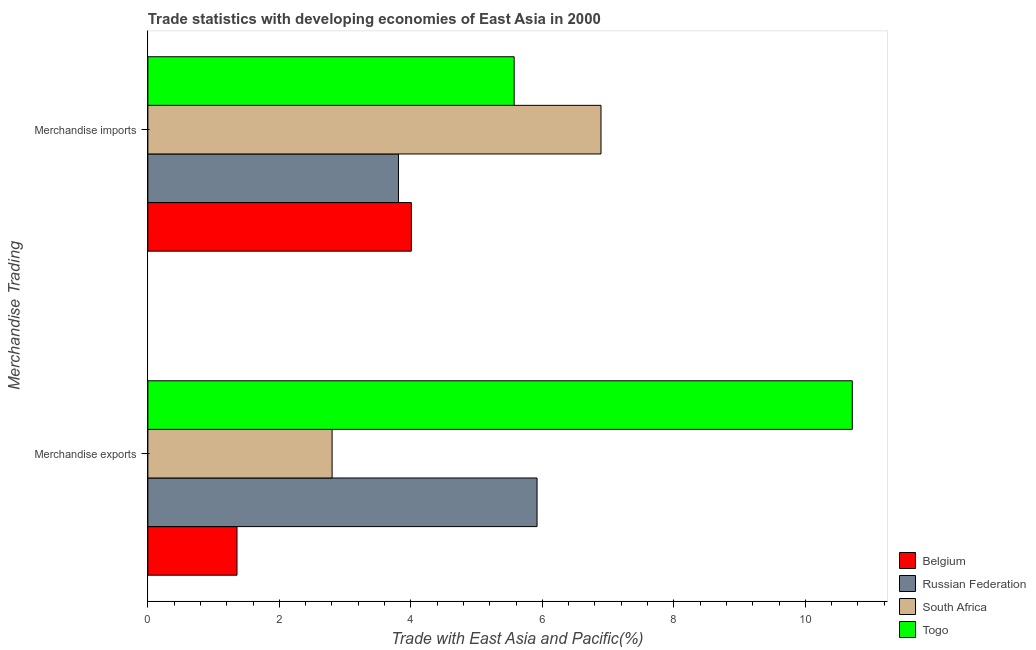Are the number of bars per tick equal to the number of legend labels?
Provide a short and direct response. Yes. Are the number of bars on each tick of the Y-axis equal?
Make the answer very short. Yes. How many bars are there on the 2nd tick from the top?
Provide a short and direct response. 4. How many bars are there on the 1st tick from the bottom?
Give a very brief answer. 4. What is the label of the 2nd group of bars from the top?
Provide a short and direct response. Merchandise exports. What is the merchandise imports in Belgium?
Provide a short and direct response. 4.01. Across all countries, what is the maximum merchandise exports?
Offer a very short reply. 10.71. Across all countries, what is the minimum merchandise exports?
Offer a very short reply. 1.36. In which country was the merchandise imports maximum?
Provide a short and direct response. South Africa. In which country was the merchandise imports minimum?
Ensure brevity in your answer.  Russian Federation. What is the total merchandise exports in the graph?
Your answer should be very brief. 20.79. What is the difference between the merchandise exports in Togo and that in Belgium?
Give a very brief answer. 9.36. What is the difference between the merchandise imports in Togo and the merchandise exports in Belgium?
Provide a short and direct response. 4.22. What is the average merchandise exports per country?
Your answer should be very brief. 5.2. What is the difference between the merchandise imports and merchandise exports in Belgium?
Offer a terse response. 2.65. In how many countries, is the merchandise exports greater than 9.6 %?
Offer a very short reply. 1. What is the ratio of the merchandise imports in Belgium to that in South Africa?
Your answer should be very brief. 0.58. Is the merchandise imports in Togo less than that in South Africa?
Provide a succinct answer. Yes. What does the 2nd bar from the top in Merchandise imports represents?
Your answer should be very brief. South Africa. Are all the bars in the graph horizontal?
Make the answer very short. Yes. How many countries are there in the graph?
Your answer should be compact. 4. Are the values on the major ticks of X-axis written in scientific E-notation?
Make the answer very short. No. Where does the legend appear in the graph?
Your response must be concise. Bottom right. What is the title of the graph?
Make the answer very short. Trade statistics with developing economies of East Asia in 2000. What is the label or title of the X-axis?
Offer a very short reply. Trade with East Asia and Pacific(%). What is the label or title of the Y-axis?
Offer a very short reply. Merchandise Trading. What is the Trade with East Asia and Pacific(%) in Belgium in Merchandise exports?
Ensure brevity in your answer.  1.36. What is the Trade with East Asia and Pacific(%) of Russian Federation in Merchandise exports?
Give a very brief answer. 5.92. What is the Trade with East Asia and Pacific(%) in South Africa in Merchandise exports?
Give a very brief answer. 2.8. What is the Trade with East Asia and Pacific(%) in Togo in Merchandise exports?
Make the answer very short. 10.71. What is the Trade with East Asia and Pacific(%) of Belgium in Merchandise imports?
Your answer should be very brief. 4.01. What is the Trade with East Asia and Pacific(%) in Russian Federation in Merchandise imports?
Make the answer very short. 3.81. What is the Trade with East Asia and Pacific(%) in South Africa in Merchandise imports?
Ensure brevity in your answer.  6.89. What is the Trade with East Asia and Pacific(%) of Togo in Merchandise imports?
Give a very brief answer. 5.57. Across all Merchandise Trading, what is the maximum Trade with East Asia and Pacific(%) in Belgium?
Give a very brief answer. 4.01. Across all Merchandise Trading, what is the maximum Trade with East Asia and Pacific(%) of Russian Federation?
Make the answer very short. 5.92. Across all Merchandise Trading, what is the maximum Trade with East Asia and Pacific(%) of South Africa?
Keep it short and to the point. 6.89. Across all Merchandise Trading, what is the maximum Trade with East Asia and Pacific(%) of Togo?
Your answer should be compact. 10.71. Across all Merchandise Trading, what is the minimum Trade with East Asia and Pacific(%) of Belgium?
Offer a very short reply. 1.36. Across all Merchandise Trading, what is the minimum Trade with East Asia and Pacific(%) in Russian Federation?
Offer a terse response. 3.81. Across all Merchandise Trading, what is the minimum Trade with East Asia and Pacific(%) of South Africa?
Your answer should be compact. 2.8. Across all Merchandise Trading, what is the minimum Trade with East Asia and Pacific(%) in Togo?
Provide a short and direct response. 5.57. What is the total Trade with East Asia and Pacific(%) in Belgium in the graph?
Ensure brevity in your answer.  5.36. What is the total Trade with East Asia and Pacific(%) in Russian Federation in the graph?
Make the answer very short. 9.73. What is the total Trade with East Asia and Pacific(%) in South Africa in the graph?
Give a very brief answer. 9.69. What is the total Trade with East Asia and Pacific(%) in Togo in the graph?
Provide a succinct answer. 16.28. What is the difference between the Trade with East Asia and Pacific(%) of Belgium in Merchandise exports and that in Merchandise imports?
Give a very brief answer. -2.65. What is the difference between the Trade with East Asia and Pacific(%) of Russian Federation in Merchandise exports and that in Merchandise imports?
Provide a succinct answer. 2.11. What is the difference between the Trade with East Asia and Pacific(%) in South Africa in Merchandise exports and that in Merchandise imports?
Offer a terse response. -4.09. What is the difference between the Trade with East Asia and Pacific(%) in Togo in Merchandise exports and that in Merchandise imports?
Ensure brevity in your answer.  5.14. What is the difference between the Trade with East Asia and Pacific(%) in Belgium in Merchandise exports and the Trade with East Asia and Pacific(%) in Russian Federation in Merchandise imports?
Give a very brief answer. -2.46. What is the difference between the Trade with East Asia and Pacific(%) in Belgium in Merchandise exports and the Trade with East Asia and Pacific(%) in South Africa in Merchandise imports?
Your answer should be compact. -5.54. What is the difference between the Trade with East Asia and Pacific(%) of Belgium in Merchandise exports and the Trade with East Asia and Pacific(%) of Togo in Merchandise imports?
Provide a short and direct response. -4.22. What is the difference between the Trade with East Asia and Pacific(%) of Russian Federation in Merchandise exports and the Trade with East Asia and Pacific(%) of South Africa in Merchandise imports?
Make the answer very short. -0.97. What is the difference between the Trade with East Asia and Pacific(%) in Russian Federation in Merchandise exports and the Trade with East Asia and Pacific(%) in Togo in Merchandise imports?
Keep it short and to the point. 0.35. What is the difference between the Trade with East Asia and Pacific(%) in South Africa in Merchandise exports and the Trade with East Asia and Pacific(%) in Togo in Merchandise imports?
Provide a succinct answer. -2.77. What is the average Trade with East Asia and Pacific(%) in Belgium per Merchandise Trading?
Provide a succinct answer. 2.68. What is the average Trade with East Asia and Pacific(%) in Russian Federation per Merchandise Trading?
Offer a terse response. 4.87. What is the average Trade with East Asia and Pacific(%) of South Africa per Merchandise Trading?
Ensure brevity in your answer.  4.85. What is the average Trade with East Asia and Pacific(%) in Togo per Merchandise Trading?
Provide a succinct answer. 8.14. What is the difference between the Trade with East Asia and Pacific(%) of Belgium and Trade with East Asia and Pacific(%) of Russian Federation in Merchandise exports?
Your response must be concise. -4.56. What is the difference between the Trade with East Asia and Pacific(%) of Belgium and Trade with East Asia and Pacific(%) of South Africa in Merchandise exports?
Provide a succinct answer. -1.45. What is the difference between the Trade with East Asia and Pacific(%) of Belgium and Trade with East Asia and Pacific(%) of Togo in Merchandise exports?
Your answer should be compact. -9.36. What is the difference between the Trade with East Asia and Pacific(%) of Russian Federation and Trade with East Asia and Pacific(%) of South Africa in Merchandise exports?
Your response must be concise. 3.12. What is the difference between the Trade with East Asia and Pacific(%) of Russian Federation and Trade with East Asia and Pacific(%) of Togo in Merchandise exports?
Give a very brief answer. -4.79. What is the difference between the Trade with East Asia and Pacific(%) of South Africa and Trade with East Asia and Pacific(%) of Togo in Merchandise exports?
Your response must be concise. -7.91. What is the difference between the Trade with East Asia and Pacific(%) in Belgium and Trade with East Asia and Pacific(%) in Russian Federation in Merchandise imports?
Ensure brevity in your answer.  0.2. What is the difference between the Trade with East Asia and Pacific(%) of Belgium and Trade with East Asia and Pacific(%) of South Africa in Merchandise imports?
Your answer should be very brief. -2.88. What is the difference between the Trade with East Asia and Pacific(%) in Belgium and Trade with East Asia and Pacific(%) in Togo in Merchandise imports?
Your answer should be very brief. -1.56. What is the difference between the Trade with East Asia and Pacific(%) in Russian Federation and Trade with East Asia and Pacific(%) in South Africa in Merchandise imports?
Give a very brief answer. -3.08. What is the difference between the Trade with East Asia and Pacific(%) of Russian Federation and Trade with East Asia and Pacific(%) of Togo in Merchandise imports?
Your answer should be very brief. -1.76. What is the difference between the Trade with East Asia and Pacific(%) of South Africa and Trade with East Asia and Pacific(%) of Togo in Merchandise imports?
Your answer should be compact. 1.32. What is the ratio of the Trade with East Asia and Pacific(%) in Belgium in Merchandise exports to that in Merchandise imports?
Offer a very short reply. 0.34. What is the ratio of the Trade with East Asia and Pacific(%) in Russian Federation in Merchandise exports to that in Merchandise imports?
Offer a terse response. 1.55. What is the ratio of the Trade with East Asia and Pacific(%) in South Africa in Merchandise exports to that in Merchandise imports?
Your response must be concise. 0.41. What is the ratio of the Trade with East Asia and Pacific(%) of Togo in Merchandise exports to that in Merchandise imports?
Provide a short and direct response. 1.92. What is the difference between the highest and the second highest Trade with East Asia and Pacific(%) in Belgium?
Offer a terse response. 2.65. What is the difference between the highest and the second highest Trade with East Asia and Pacific(%) of Russian Federation?
Your response must be concise. 2.11. What is the difference between the highest and the second highest Trade with East Asia and Pacific(%) of South Africa?
Your answer should be very brief. 4.09. What is the difference between the highest and the second highest Trade with East Asia and Pacific(%) in Togo?
Ensure brevity in your answer.  5.14. What is the difference between the highest and the lowest Trade with East Asia and Pacific(%) in Belgium?
Your response must be concise. 2.65. What is the difference between the highest and the lowest Trade with East Asia and Pacific(%) in Russian Federation?
Provide a succinct answer. 2.11. What is the difference between the highest and the lowest Trade with East Asia and Pacific(%) of South Africa?
Give a very brief answer. 4.09. What is the difference between the highest and the lowest Trade with East Asia and Pacific(%) in Togo?
Keep it short and to the point. 5.14. 